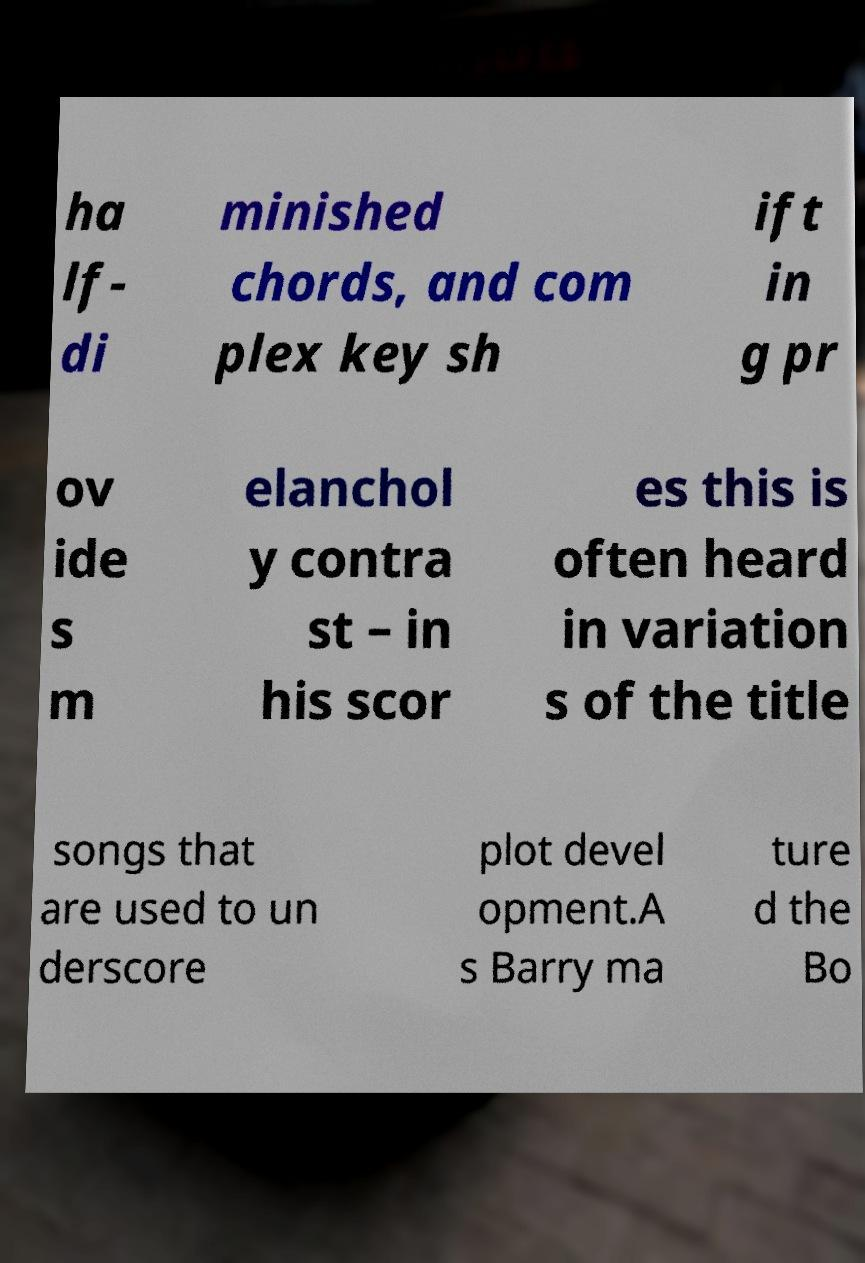Could you assist in decoding the text presented in this image and type it out clearly? ha lf- di minished chords, and com plex key sh ift in g pr ov ide s m elanchol y contra st – in his scor es this is often heard in variation s of the title songs that are used to un derscore plot devel opment.A s Barry ma ture d the Bo 